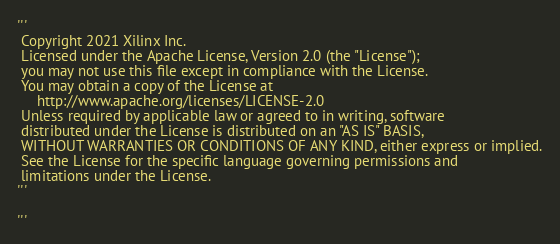<code> <loc_0><loc_0><loc_500><loc_500><_Python_>'''
 Copyright 2021 Xilinx Inc.
 Licensed under the Apache License, Version 2.0 (the "License");
 you may not use this file except in compliance with the License.
 You may obtain a copy of the License at
     http://www.apache.org/licenses/LICENSE-2.0
 Unless required by applicable law or agreed to in writing, software
 distributed under the License is distributed on an "AS IS" BASIS,
 WITHOUT WARRANTIES OR CONDITIONS OF ANY KIND, either express or implied.
 See the License for the specific language governing permissions and
 limitations under the License.
'''

'''</code> 